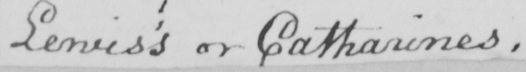Please provide the text content of this handwritten line. Lewis ' s or Catharines . 